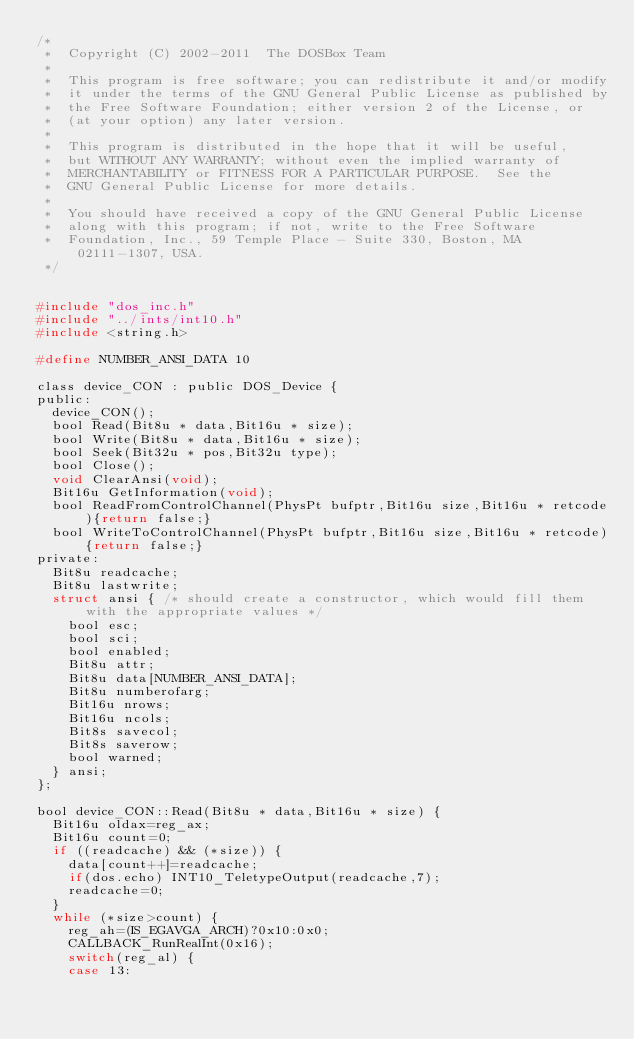<code> <loc_0><loc_0><loc_500><loc_500><_C_>/*
 *  Copyright (C) 2002-2011  The DOSBox Team
 *
 *  This program is free software; you can redistribute it and/or modify
 *  it under the terms of the GNU General Public License as published by
 *  the Free Software Foundation; either version 2 of the License, or
 *  (at your option) any later version.
 *
 *  This program is distributed in the hope that it will be useful,
 *  but WITHOUT ANY WARRANTY; without even the implied warranty of
 *  MERCHANTABILITY or FITNESS FOR A PARTICULAR PURPOSE.  See the
 *  GNU General Public License for more details.
 *
 *  You should have received a copy of the GNU General Public License
 *  along with this program; if not, write to the Free Software
 *  Foundation, Inc., 59 Temple Place - Suite 330, Boston, MA 02111-1307, USA.
 */


#include "dos_inc.h"
#include "../ints/int10.h"
#include <string.h>

#define NUMBER_ANSI_DATA 10

class device_CON : public DOS_Device {
public:
	device_CON();
	bool Read(Bit8u * data,Bit16u * size);
	bool Write(Bit8u * data,Bit16u * size);
	bool Seek(Bit32u * pos,Bit32u type);
	bool Close();
	void ClearAnsi(void);
	Bit16u GetInformation(void);
	bool ReadFromControlChannel(PhysPt bufptr,Bit16u size,Bit16u * retcode){return false;}
	bool WriteToControlChannel(PhysPt bufptr,Bit16u size,Bit16u * retcode){return false;}
private:
	Bit8u readcache;
	Bit8u lastwrite;
	struct ansi { /* should create a constructor, which would fill them with the appropriate values */
		bool esc;
		bool sci;
		bool enabled;
		Bit8u attr;
		Bit8u data[NUMBER_ANSI_DATA];
		Bit8u numberofarg;
		Bit16u nrows;
		Bit16u ncols;
		Bit8s savecol;
		Bit8s saverow;
		bool warned;
	} ansi;
};

bool device_CON::Read(Bit8u * data,Bit16u * size) {
	Bit16u oldax=reg_ax;
	Bit16u count=0;
	if ((readcache) && (*size)) {
		data[count++]=readcache;
		if(dos.echo) INT10_TeletypeOutput(readcache,7);
		readcache=0;
	}
	while (*size>count) {
		reg_ah=(IS_EGAVGA_ARCH)?0x10:0x0;
		CALLBACK_RunRealInt(0x16);
		switch(reg_al) {
		case 13:</code> 